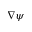<formula> <loc_0><loc_0><loc_500><loc_500>\nabla \psi</formula> 